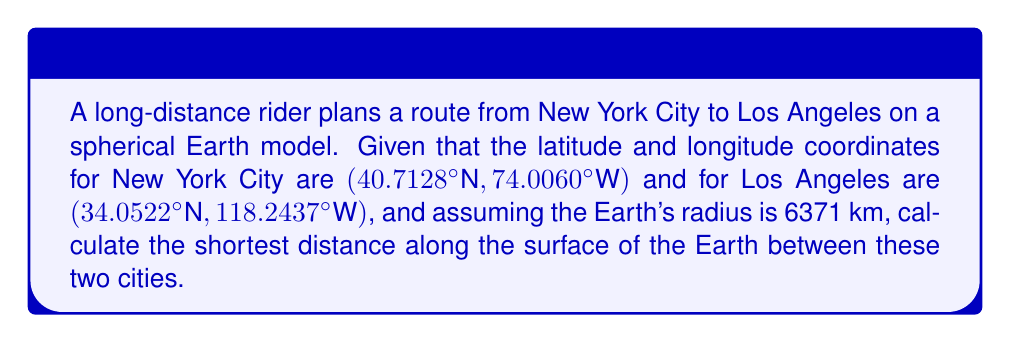Show me your answer to this math problem. To find the shortest path between two points on a spherical surface, we need to calculate the great circle distance. This can be done using the Haversine formula:

1) Convert the coordinates from degrees to radians:
   $\phi_1 = 40.7128° \times \frac{\pi}{180} = 0.7102$ rad
   $\lambda_1 = -74.0060° \times \frac{\pi}{180} = -1.2915$ rad
   $\phi_2 = 34.0522° \times \frac{\pi}{180} = 0.5942$ rad
   $\lambda_2 = -118.2437° \times \frac{\pi}{180} = -2.0631$ rad

2) Calculate the central angle $\Delta \sigma$ using the Haversine formula:
   $$\Delta \sigma = 2 \arcsin\left(\sqrt{\sin^2\left(\frac{\phi_2 - \phi_1}{2}\right) + \cos(\phi_1)\cos(\phi_2)\sin^2\left(\frac{\lambda_2 - \lambda_1}{2}\right)}\right)$$

3) Substitute the values:
   $$\Delta \sigma = 2 \arcsin\left(\sqrt{\sin^2\left(\frac{0.5942 - 0.7102}{2}\right) + \cos(0.7102)\cos(0.5942)\sin^2\left(\frac{-2.0631 - (-1.2915)}{2}\right)}\right)$$

4) Calculate:
   $\Delta \sigma \approx 0.6231$ rad

5) The distance $d$ is then calculated by multiplying the central angle by the Earth's radius:
   $d = R \times \Delta \sigma$
   $d = 6371 \text{ km} \times 0.6231 \text{ rad}$
   $d \approx 3969.9 \text{ km}$

Therefore, the shortest distance along the surface of the Earth between New York City and Los Angeles is approximately 3969.9 km.
Answer: 3969.9 km 